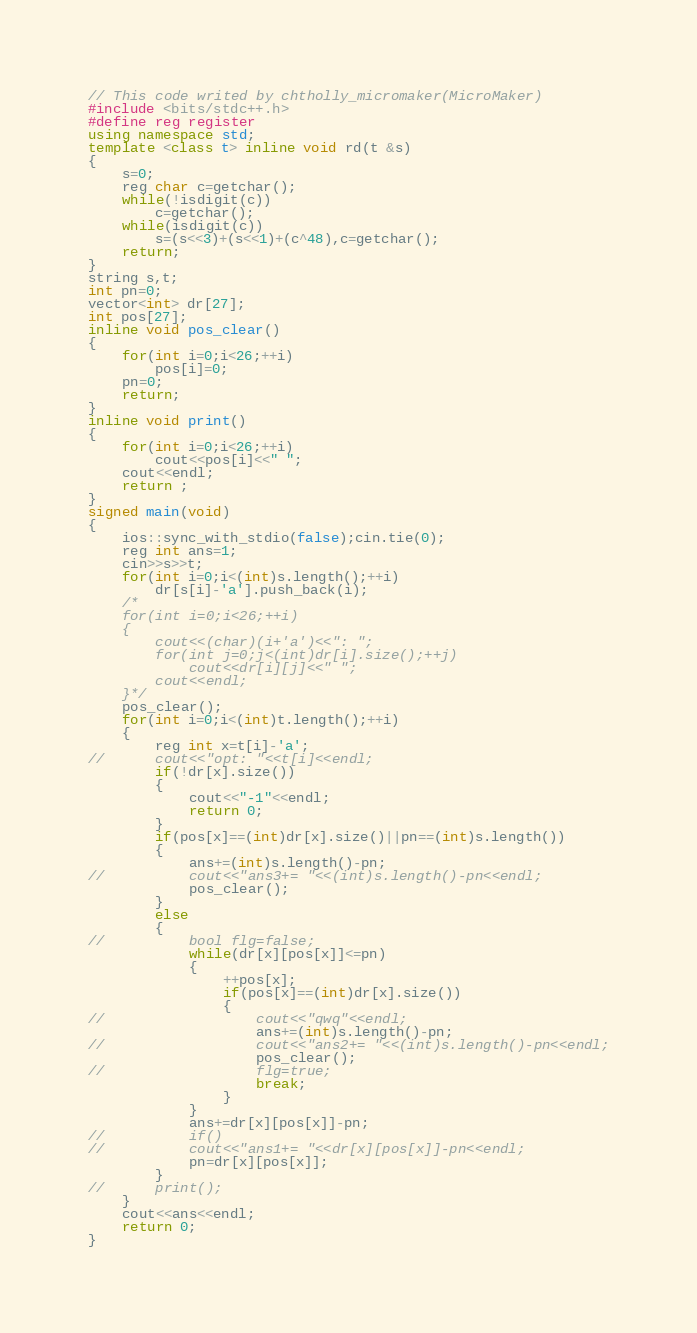Convert code to text. <code><loc_0><loc_0><loc_500><loc_500><_C++_>// This code writed by chtholly_micromaker(MicroMaker)
#include <bits/stdc++.h>
#define reg register
using namespace std;
template <class t> inline void rd(t &s)
{
	s=0;
	reg char c=getchar();
	while(!isdigit(c))
		c=getchar();
	while(isdigit(c))
		s=(s<<3)+(s<<1)+(c^48),c=getchar();
	return;
}
string s,t;
int pn=0;
vector<int> dr[27];
int pos[27];
inline void pos_clear()
{
	for(int i=0;i<26;++i)
		pos[i]=0;
	pn=0;
	return;
}
inline void print()
{
	for(int i=0;i<26;++i)
		cout<<pos[i]<<" ";
	cout<<endl;
	return ;
}
signed main(void)
{
	ios::sync_with_stdio(false);cin.tie(0);
	reg int ans=1;
	cin>>s>>t;
	for(int i=0;i<(int)s.length();++i)
		dr[s[i]-'a'].push_back(i);
	/*
	for(int i=0;i<26;++i)
	{
		cout<<(char)(i+'a')<<": ";
		for(int j=0;j<(int)dr[i].size();++j)
			cout<<dr[i][j]<<" ";
		cout<<endl;
	}*/
	pos_clear();
	for(int i=0;i<(int)t.length();++i)
	{
		reg int x=t[i]-'a';
//		cout<<"opt: "<<t[i]<<endl;
		if(!dr[x].size())
		{
			cout<<"-1"<<endl;
			return 0;
		}
		if(pos[x]==(int)dr[x].size()||pn==(int)s.length())
		{
			ans+=(int)s.length()-pn;
//			cout<<"ans3+= "<<(int)s.length()-pn<<endl;
			pos_clear();
		}
		else
		{
//			bool flg=false;
			while(dr[x][pos[x]]<=pn)
			{
				++pos[x];
				if(pos[x]==(int)dr[x].size())
				{
//					cout<<"qwq"<<endl;
					ans+=(int)s.length()-pn;
//					cout<<"ans2+= "<<(int)s.length()-pn<<endl;
					pos_clear();
//					flg=true;
					break;
				}
			}
			ans+=dr[x][pos[x]]-pn;
//			if()
//			cout<<"ans1+= "<<dr[x][pos[x]]-pn<<endl;
			pn=dr[x][pos[x]];
		}
//		print();
	}
	cout<<ans<<endl;
	return 0;
}

</code> 